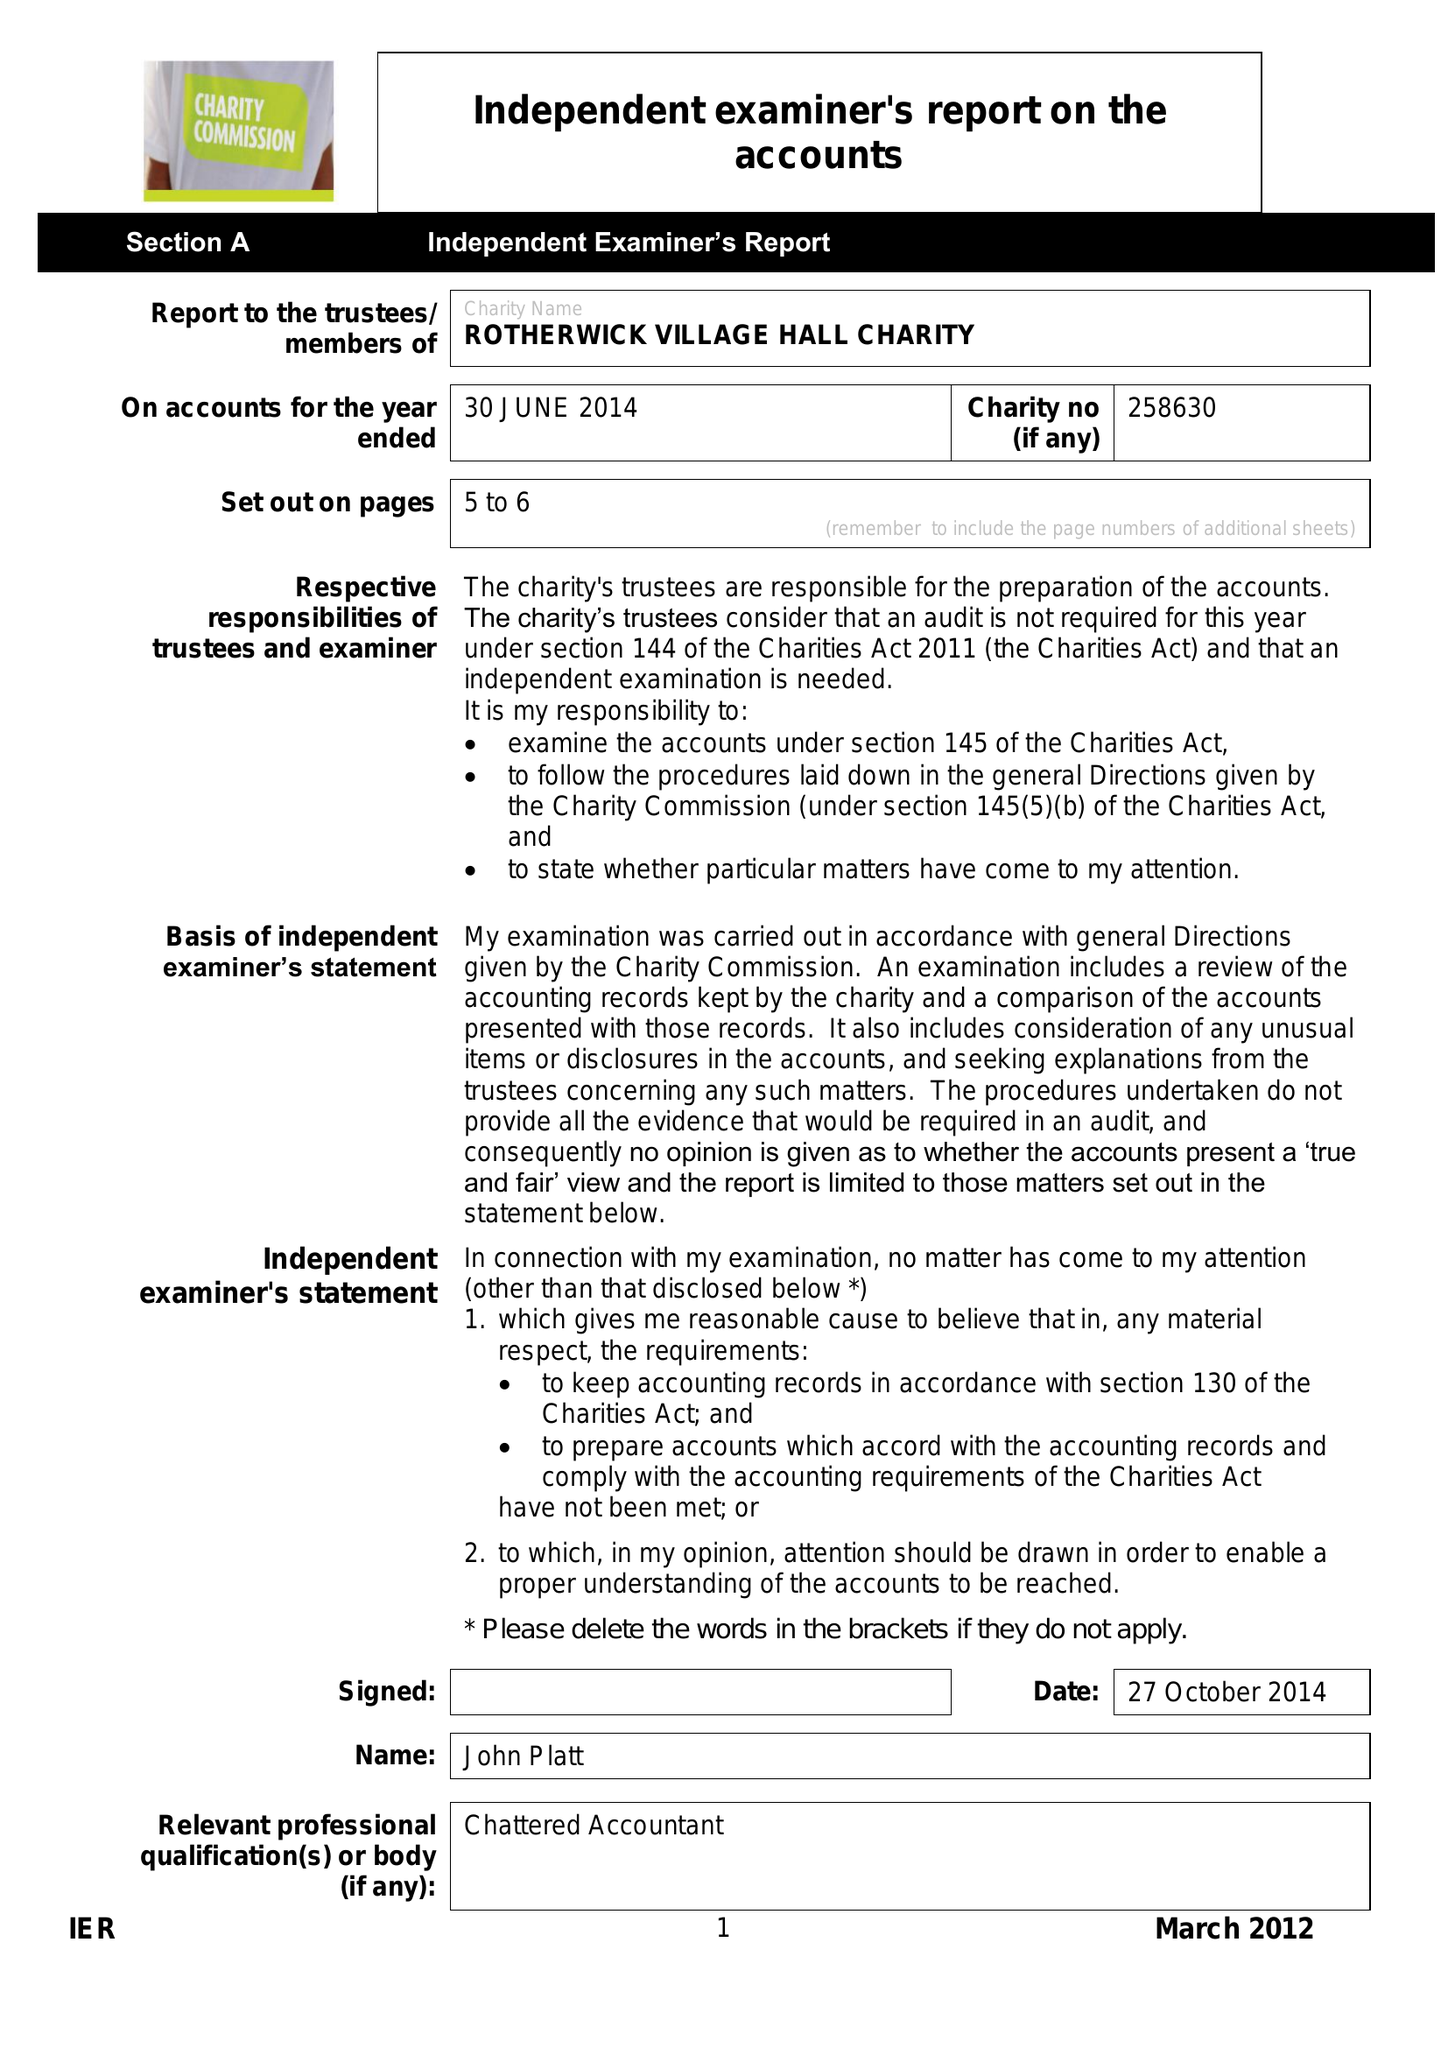What is the value for the income_annually_in_british_pounds?
Answer the question using a single word or phrase. 44880.00 